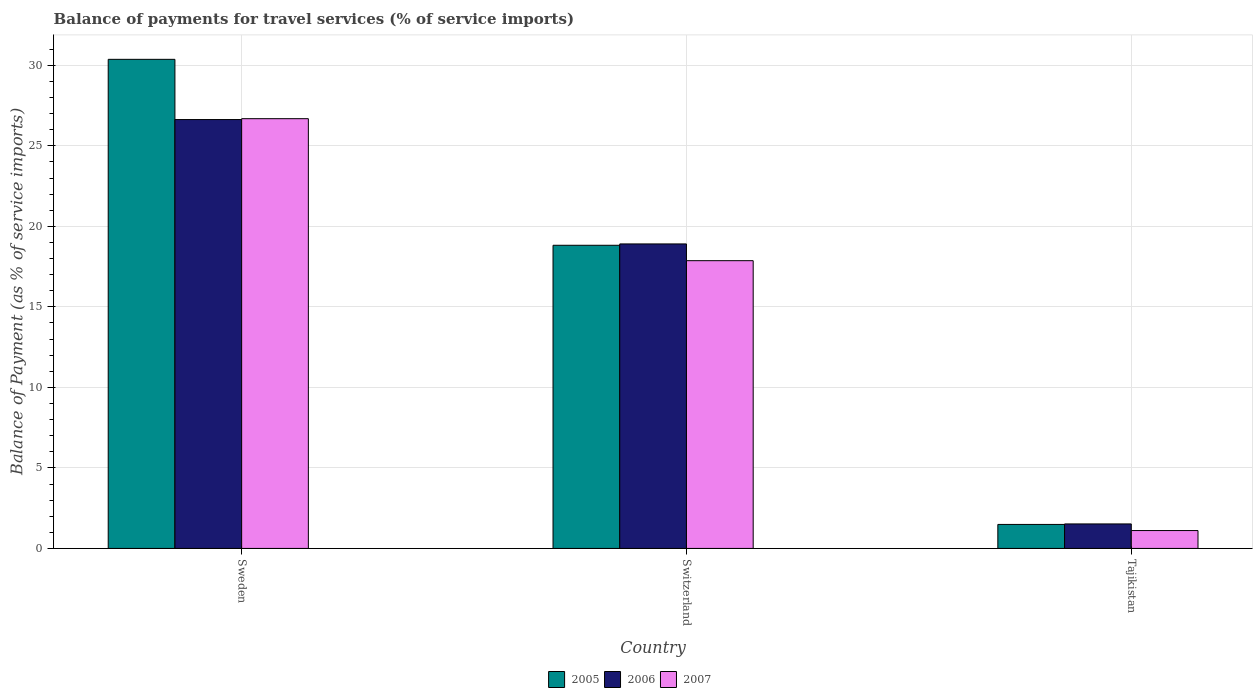How many bars are there on the 2nd tick from the left?
Ensure brevity in your answer.  3. What is the label of the 3rd group of bars from the left?
Give a very brief answer. Tajikistan. What is the balance of payments for travel services in 2007 in Tajikistan?
Offer a very short reply. 1.11. Across all countries, what is the maximum balance of payments for travel services in 2007?
Keep it short and to the point. 26.69. Across all countries, what is the minimum balance of payments for travel services in 2006?
Provide a short and direct response. 1.52. In which country was the balance of payments for travel services in 2006 minimum?
Provide a short and direct response. Tajikistan. What is the total balance of payments for travel services in 2005 in the graph?
Make the answer very short. 50.69. What is the difference between the balance of payments for travel services in 2005 in Switzerland and that in Tajikistan?
Your answer should be compact. 17.34. What is the difference between the balance of payments for travel services in 2006 in Switzerland and the balance of payments for travel services in 2007 in Sweden?
Give a very brief answer. -7.78. What is the average balance of payments for travel services in 2005 per country?
Give a very brief answer. 16.9. What is the difference between the balance of payments for travel services of/in 2005 and balance of payments for travel services of/in 2006 in Tajikistan?
Ensure brevity in your answer.  -0.03. In how many countries, is the balance of payments for travel services in 2006 greater than 4 %?
Offer a terse response. 2. What is the ratio of the balance of payments for travel services in 2007 in Sweden to that in Switzerland?
Offer a very short reply. 1.49. Is the difference between the balance of payments for travel services in 2005 in Sweden and Switzerland greater than the difference between the balance of payments for travel services in 2006 in Sweden and Switzerland?
Offer a very short reply. Yes. What is the difference between the highest and the second highest balance of payments for travel services in 2005?
Your response must be concise. -17.34. What is the difference between the highest and the lowest balance of payments for travel services in 2005?
Your response must be concise. 28.88. In how many countries, is the balance of payments for travel services in 2007 greater than the average balance of payments for travel services in 2007 taken over all countries?
Your answer should be compact. 2. Is the sum of the balance of payments for travel services in 2007 in Switzerland and Tajikistan greater than the maximum balance of payments for travel services in 2005 across all countries?
Your answer should be compact. No. What does the 2nd bar from the right in Sweden represents?
Your answer should be compact. 2006. Is it the case that in every country, the sum of the balance of payments for travel services in 2007 and balance of payments for travel services in 2006 is greater than the balance of payments for travel services in 2005?
Offer a very short reply. Yes. What is the difference between two consecutive major ticks on the Y-axis?
Make the answer very short. 5. Does the graph contain grids?
Provide a succinct answer. Yes. What is the title of the graph?
Provide a short and direct response. Balance of payments for travel services (% of service imports). Does "1975" appear as one of the legend labels in the graph?
Keep it short and to the point. No. What is the label or title of the Y-axis?
Make the answer very short. Balance of Payment (as % of service imports). What is the Balance of Payment (as % of service imports) in 2005 in Sweden?
Your answer should be very brief. 30.37. What is the Balance of Payment (as % of service imports) in 2006 in Sweden?
Your answer should be very brief. 26.63. What is the Balance of Payment (as % of service imports) of 2007 in Sweden?
Ensure brevity in your answer.  26.69. What is the Balance of Payment (as % of service imports) in 2005 in Switzerland?
Give a very brief answer. 18.83. What is the Balance of Payment (as % of service imports) of 2006 in Switzerland?
Give a very brief answer. 18.91. What is the Balance of Payment (as % of service imports) in 2007 in Switzerland?
Your answer should be very brief. 17.87. What is the Balance of Payment (as % of service imports) of 2005 in Tajikistan?
Your answer should be compact. 1.49. What is the Balance of Payment (as % of service imports) of 2006 in Tajikistan?
Your answer should be compact. 1.52. What is the Balance of Payment (as % of service imports) of 2007 in Tajikistan?
Make the answer very short. 1.11. Across all countries, what is the maximum Balance of Payment (as % of service imports) in 2005?
Keep it short and to the point. 30.37. Across all countries, what is the maximum Balance of Payment (as % of service imports) of 2006?
Offer a terse response. 26.63. Across all countries, what is the maximum Balance of Payment (as % of service imports) of 2007?
Offer a very short reply. 26.69. Across all countries, what is the minimum Balance of Payment (as % of service imports) in 2005?
Offer a terse response. 1.49. Across all countries, what is the minimum Balance of Payment (as % of service imports) of 2006?
Provide a short and direct response. 1.52. Across all countries, what is the minimum Balance of Payment (as % of service imports) of 2007?
Your response must be concise. 1.11. What is the total Balance of Payment (as % of service imports) in 2005 in the graph?
Your answer should be very brief. 50.69. What is the total Balance of Payment (as % of service imports) of 2006 in the graph?
Provide a short and direct response. 47.07. What is the total Balance of Payment (as % of service imports) of 2007 in the graph?
Offer a very short reply. 45.67. What is the difference between the Balance of Payment (as % of service imports) in 2005 in Sweden and that in Switzerland?
Make the answer very short. 11.55. What is the difference between the Balance of Payment (as % of service imports) of 2006 in Sweden and that in Switzerland?
Make the answer very short. 7.72. What is the difference between the Balance of Payment (as % of service imports) of 2007 in Sweden and that in Switzerland?
Keep it short and to the point. 8.82. What is the difference between the Balance of Payment (as % of service imports) in 2005 in Sweden and that in Tajikistan?
Keep it short and to the point. 28.88. What is the difference between the Balance of Payment (as % of service imports) of 2006 in Sweden and that in Tajikistan?
Make the answer very short. 25.11. What is the difference between the Balance of Payment (as % of service imports) of 2007 in Sweden and that in Tajikistan?
Make the answer very short. 25.58. What is the difference between the Balance of Payment (as % of service imports) in 2005 in Switzerland and that in Tajikistan?
Ensure brevity in your answer.  17.34. What is the difference between the Balance of Payment (as % of service imports) of 2006 in Switzerland and that in Tajikistan?
Provide a succinct answer. 17.39. What is the difference between the Balance of Payment (as % of service imports) in 2007 in Switzerland and that in Tajikistan?
Make the answer very short. 16.76. What is the difference between the Balance of Payment (as % of service imports) in 2005 in Sweden and the Balance of Payment (as % of service imports) in 2006 in Switzerland?
Ensure brevity in your answer.  11.46. What is the difference between the Balance of Payment (as % of service imports) of 2005 in Sweden and the Balance of Payment (as % of service imports) of 2007 in Switzerland?
Offer a terse response. 12.5. What is the difference between the Balance of Payment (as % of service imports) in 2006 in Sweden and the Balance of Payment (as % of service imports) in 2007 in Switzerland?
Your answer should be very brief. 8.76. What is the difference between the Balance of Payment (as % of service imports) of 2005 in Sweden and the Balance of Payment (as % of service imports) of 2006 in Tajikistan?
Offer a very short reply. 28.85. What is the difference between the Balance of Payment (as % of service imports) in 2005 in Sweden and the Balance of Payment (as % of service imports) in 2007 in Tajikistan?
Keep it short and to the point. 29.26. What is the difference between the Balance of Payment (as % of service imports) of 2006 in Sweden and the Balance of Payment (as % of service imports) of 2007 in Tajikistan?
Your answer should be compact. 25.52. What is the difference between the Balance of Payment (as % of service imports) of 2005 in Switzerland and the Balance of Payment (as % of service imports) of 2006 in Tajikistan?
Your answer should be very brief. 17.3. What is the difference between the Balance of Payment (as % of service imports) in 2005 in Switzerland and the Balance of Payment (as % of service imports) in 2007 in Tajikistan?
Your answer should be compact. 17.72. What is the difference between the Balance of Payment (as % of service imports) in 2006 in Switzerland and the Balance of Payment (as % of service imports) in 2007 in Tajikistan?
Ensure brevity in your answer.  17.8. What is the average Balance of Payment (as % of service imports) of 2005 per country?
Offer a very short reply. 16.9. What is the average Balance of Payment (as % of service imports) in 2006 per country?
Ensure brevity in your answer.  15.69. What is the average Balance of Payment (as % of service imports) of 2007 per country?
Your response must be concise. 15.22. What is the difference between the Balance of Payment (as % of service imports) in 2005 and Balance of Payment (as % of service imports) in 2006 in Sweden?
Keep it short and to the point. 3.74. What is the difference between the Balance of Payment (as % of service imports) in 2005 and Balance of Payment (as % of service imports) in 2007 in Sweden?
Offer a terse response. 3.69. What is the difference between the Balance of Payment (as % of service imports) of 2006 and Balance of Payment (as % of service imports) of 2007 in Sweden?
Provide a short and direct response. -0.06. What is the difference between the Balance of Payment (as % of service imports) of 2005 and Balance of Payment (as % of service imports) of 2006 in Switzerland?
Your answer should be very brief. -0.08. What is the difference between the Balance of Payment (as % of service imports) in 2005 and Balance of Payment (as % of service imports) in 2007 in Switzerland?
Offer a terse response. 0.96. What is the difference between the Balance of Payment (as % of service imports) in 2006 and Balance of Payment (as % of service imports) in 2007 in Switzerland?
Make the answer very short. 1.04. What is the difference between the Balance of Payment (as % of service imports) of 2005 and Balance of Payment (as % of service imports) of 2006 in Tajikistan?
Make the answer very short. -0.03. What is the difference between the Balance of Payment (as % of service imports) in 2005 and Balance of Payment (as % of service imports) in 2007 in Tajikistan?
Offer a very short reply. 0.38. What is the difference between the Balance of Payment (as % of service imports) in 2006 and Balance of Payment (as % of service imports) in 2007 in Tajikistan?
Offer a very short reply. 0.41. What is the ratio of the Balance of Payment (as % of service imports) of 2005 in Sweden to that in Switzerland?
Make the answer very short. 1.61. What is the ratio of the Balance of Payment (as % of service imports) in 2006 in Sweden to that in Switzerland?
Make the answer very short. 1.41. What is the ratio of the Balance of Payment (as % of service imports) of 2007 in Sweden to that in Switzerland?
Your answer should be compact. 1.49. What is the ratio of the Balance of Payment (as % of service imports) of 2005 in Sweden to that in Tajikistan?
Provide a succinct answer. 20.38. What is the ratio of the Balance of Payment (as % of service imports) of 2006 in Sweden to that in Tajikistan?
Your answer should be compact. 17.5. What is the ratio of the Balance of Payment (as % of service imports) in 2007 in Sweden to that in Tajikistan?
Keep it short and to the point. 24.04. What is the ratio of the Balance of Payment (as % of service imports) in 2005 in Switzerland to that in Tajikistan?
Your answer should be very brief. 12.63. What is the ratio of the Balance of Payment (as % of service imports) of 2006 in Switzerland to that in Tajikistan?
Offer a very short reply. 12.42. What is the ratio of the Balance of Payment (as % of service imports) of 2007 in Switzerland to that in Tajikistan?
Your answer should be compact. 16.09. What is the difference between the highest and the second highest Balance of Payment (as % of service imports) in 2005?
Make the answer very short. 11.55. What is the difference between the highest and the second highest Balance of Payment (as % of service imports) of 2006?
Keep it short and to the point. 7.72. What is the difference between the highest and the second highest Balance of Payment (as % of service imports) in 2007?
Offer a very short reply. 8.82. What is the difference between the highest and the lowest Balance of Payment (as % of service imports) of 2005?
Make the answer very short. 28.88. What is the difference between the highest and the lowest Balance of Payment (as % of service imports) of 2006?
Your response must be concise. 25.11. What is the difference between the highest and the lowest Balance of Payment (as % of service imports) in 2007?
Make the answer very short. 25.58. 